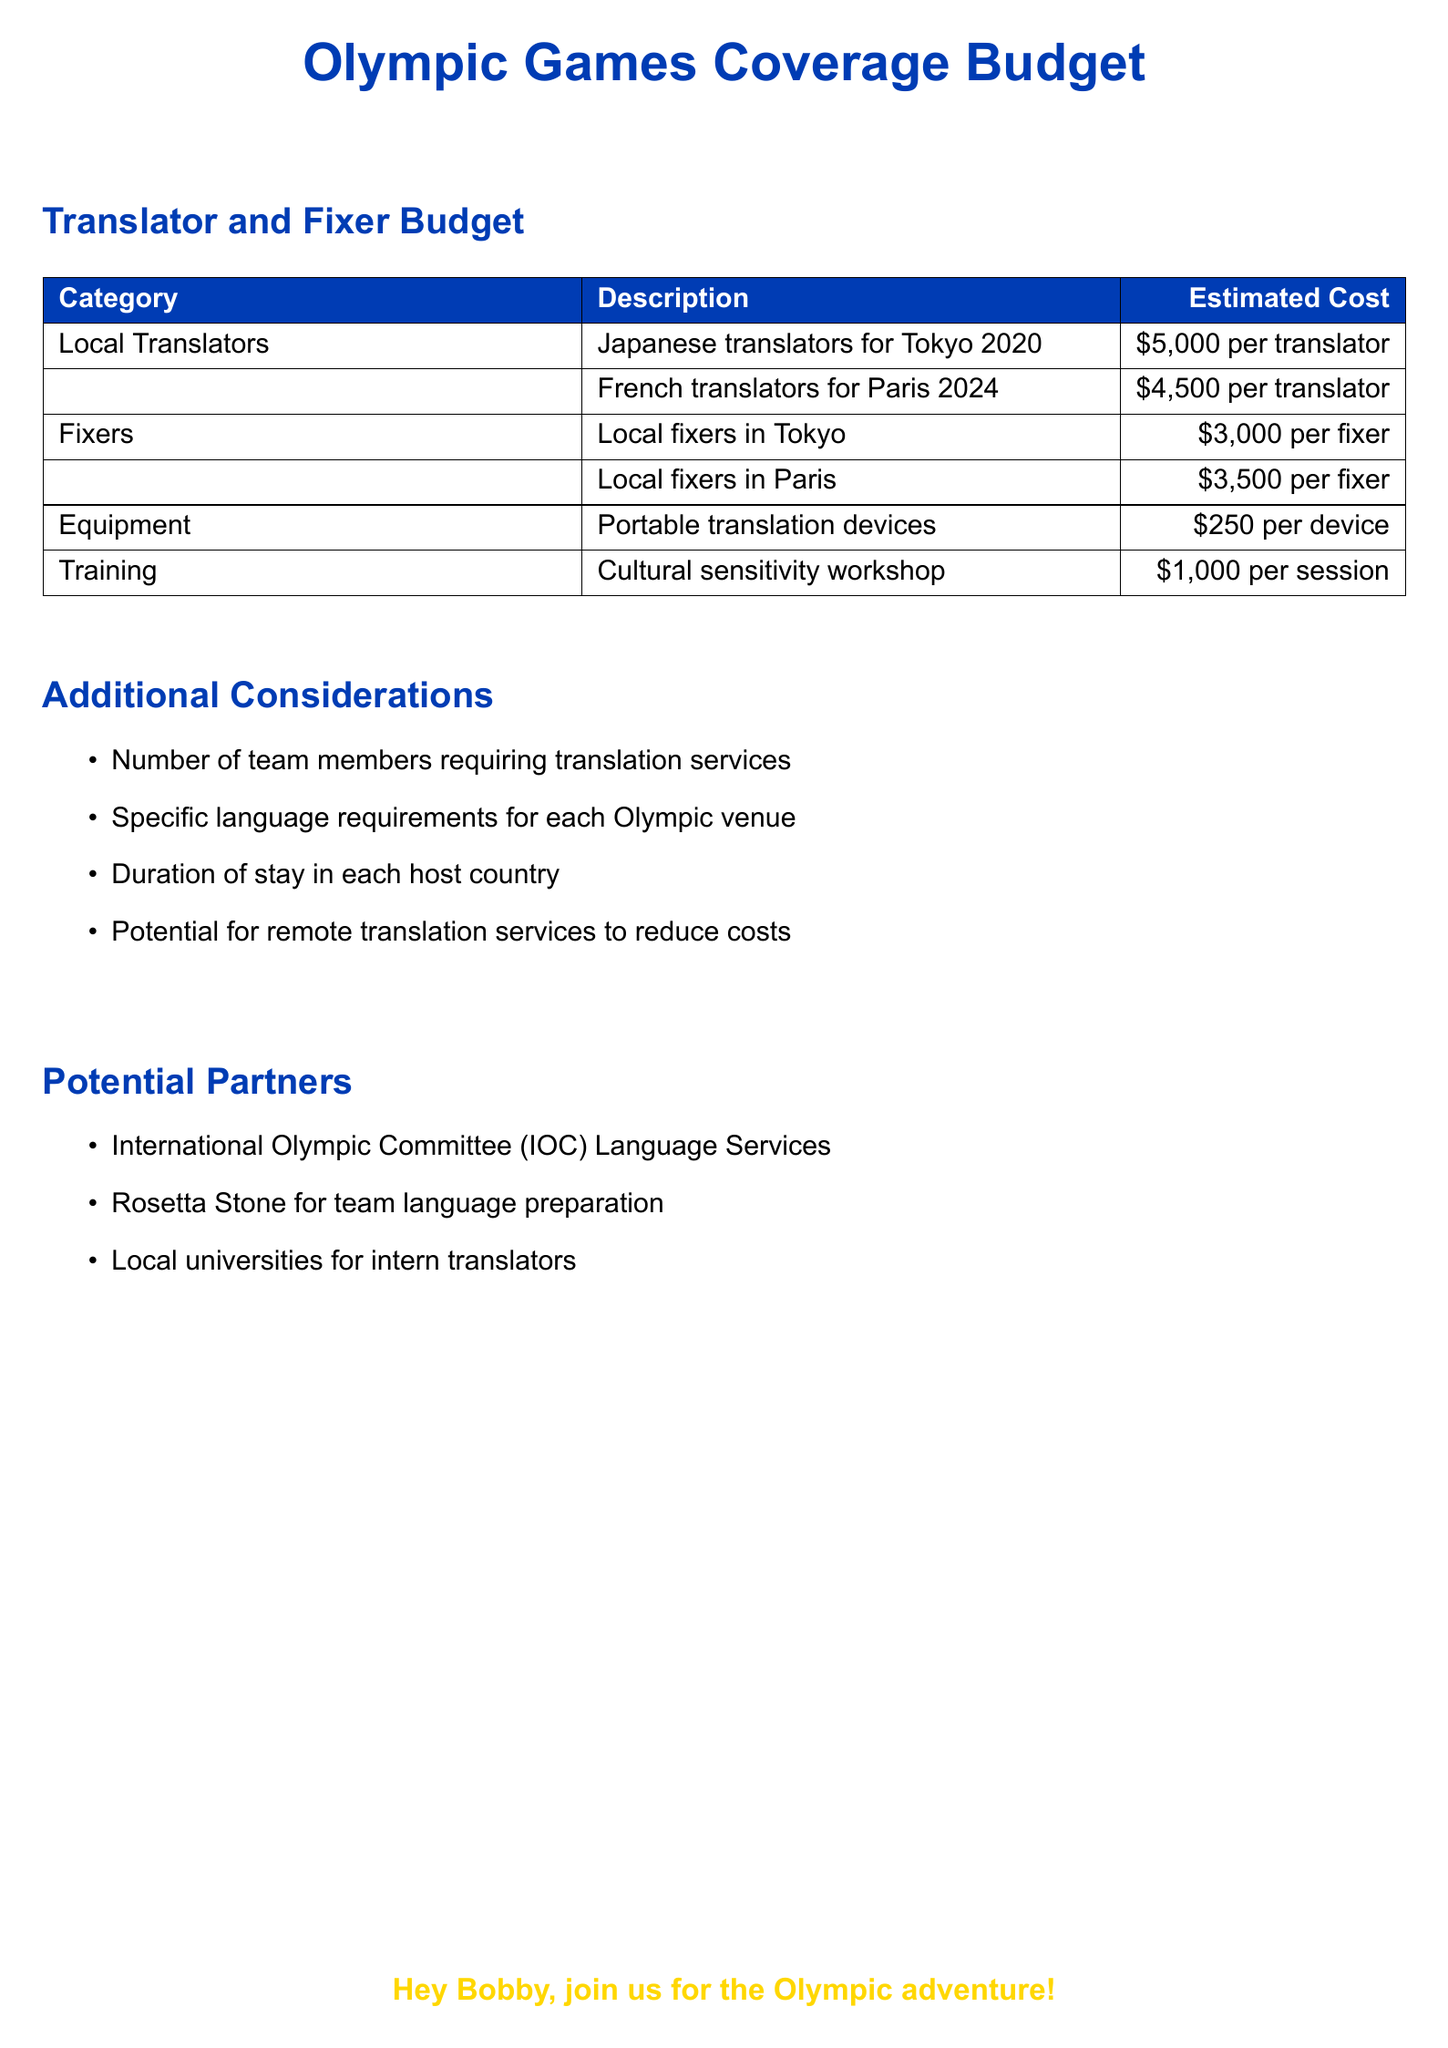What is the cost for a Japanese translator? The document specifies the cost for Japanese translators for Tokyo 2020 as $5,000 per translator.
Answer: $5,000 What is the cost for a French translator? The document states the cost for French translators for Paris 2024 as $4,500 per translator.
Answer: $4,500 How much does a local fixer in Tokyo cost? According to the document, the cost for local fixers in Tokyo is $3,000 per fixer.
Answer: $3,000 What is the estimated cost for portable translation devices? The document lists the estimated cost for portable translation devices as $250 per device.
Answer: $250 What is included in the cultural sensitivity workshop cost? The document states the session's cost as $1,000 per session for training.
Answer: $1,000 How many team members require translation services? This is mentioned as a consideration in the document and not specifically stated, prompting reasoning.
Answer: Number of team members is unspecified What potential partners are mentioned for language services? The document lists potential partners such as the International Olympic Committee (IOC) Language Services and local universities.
Answer: IOC Language Services, local universities What is one way to reduce translation costs? The document suggests considering the potential for remote translation services to reduce overall costs.
Answer: Remote translation services What event is the budget regarding? The document specifically outlines the budget for Olympic Games coverage.
Answer: Olympic Games 